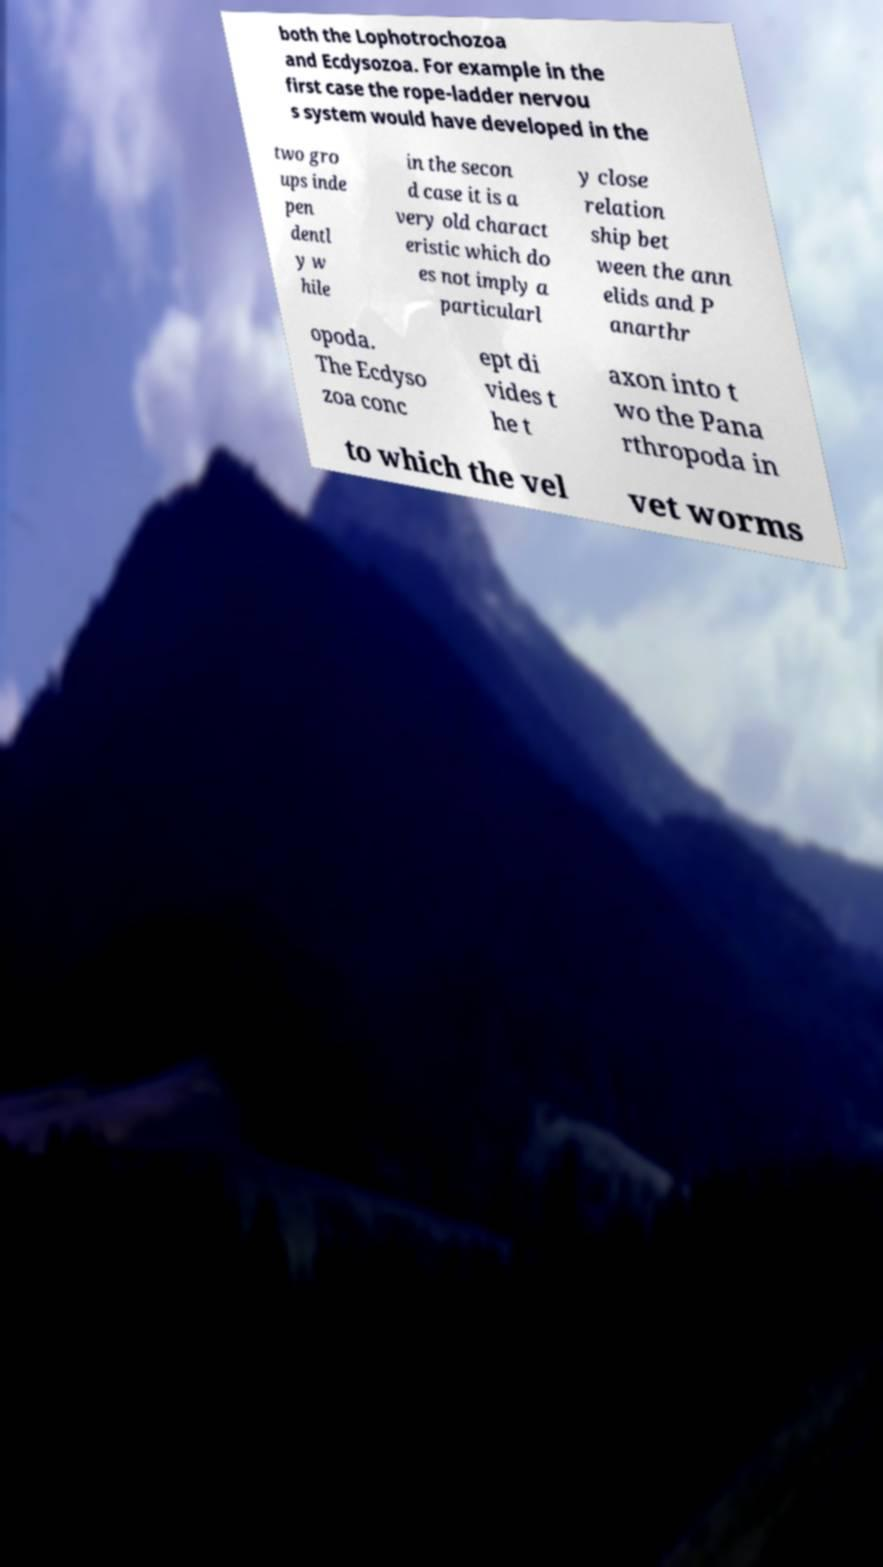Could you assist in decoding the text presented in this image and type it out clearly? both the Lophotrochozoa and Ecdysozoa. For example in the first case the rope-ladder nervou s system would have developed in the two gro ups inde pen dentl y w hile in the secon d case it is a very old charact eristic which do es not imply a particularl y close relation ship bet ween the ann elids and P anarthr opoda. The Ecdyso zoa conc ept di vides t he t axon into t wo the Pana rthropoda in to which the vel vet worms 